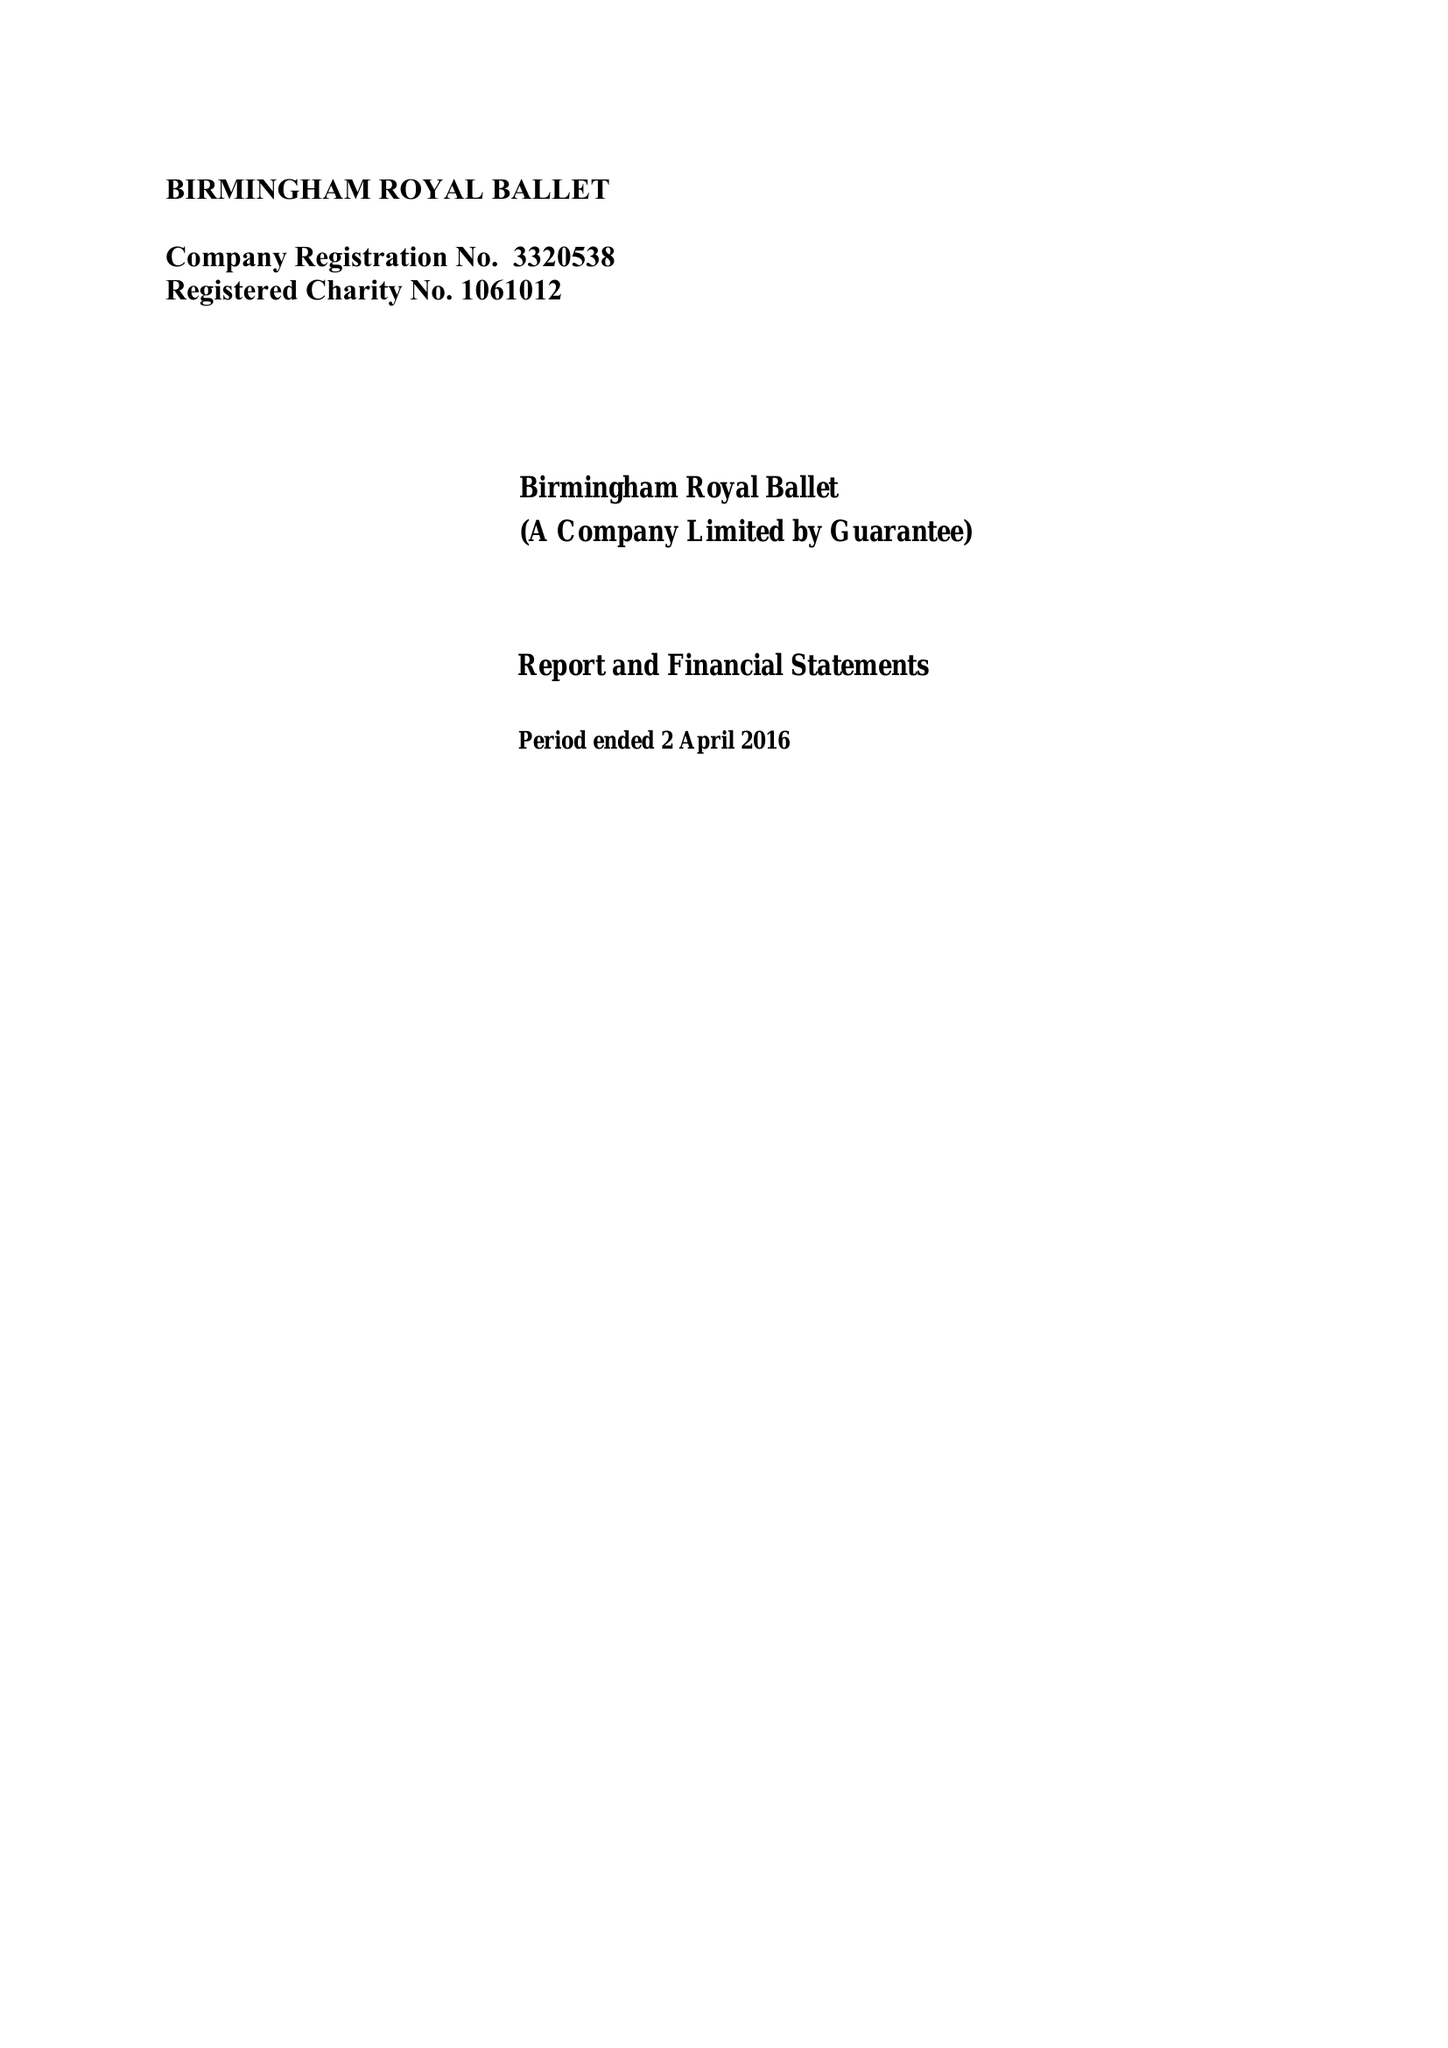What is the value for the charity_number?
Answer the question using a single word or phrase. 1061012 